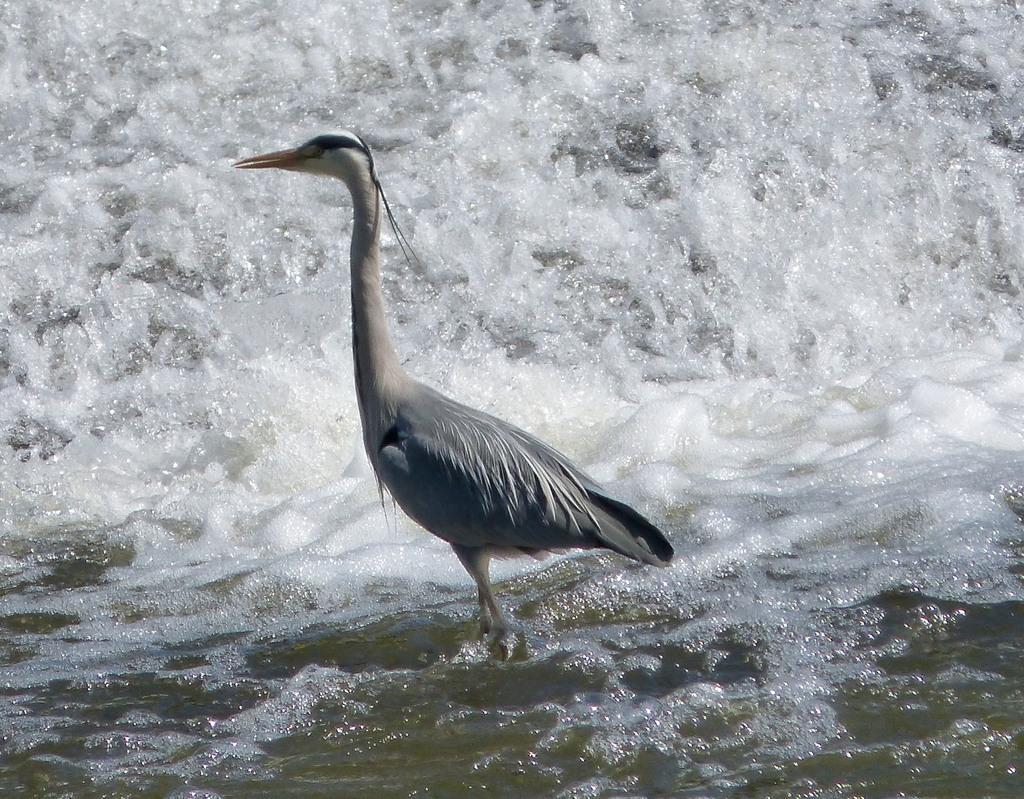Describe this image in one or two sentences. In this picture we can see a bird in the water. Waves are visible on top of the image. 